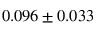<formula> <loc_0><loc_0><loc_500><loc_500>0 . 0 9 6 \pm 0 . 0 3 3</formula> 